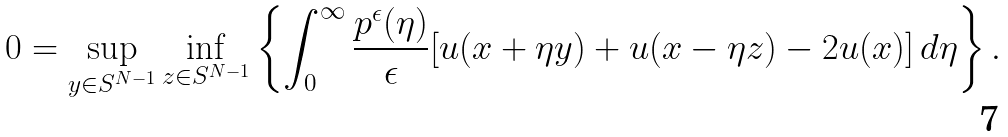<formula> <loc_0><loc_0><loc_500><loc_500>0 = \sup _ { y \in S ^ { N - 1 } } \inf _ { z \in S ^ { N - 1 } } \left \{ \int _ { 0 } ^ { \infty } \frac { p ^ { \epsilon } ( \eta ) } { \epsilon } [ u ( x + \eta y ) + u ( x - \eta z ) - 2 u ( x ) ] \, d \eta \right \} .</formula> 